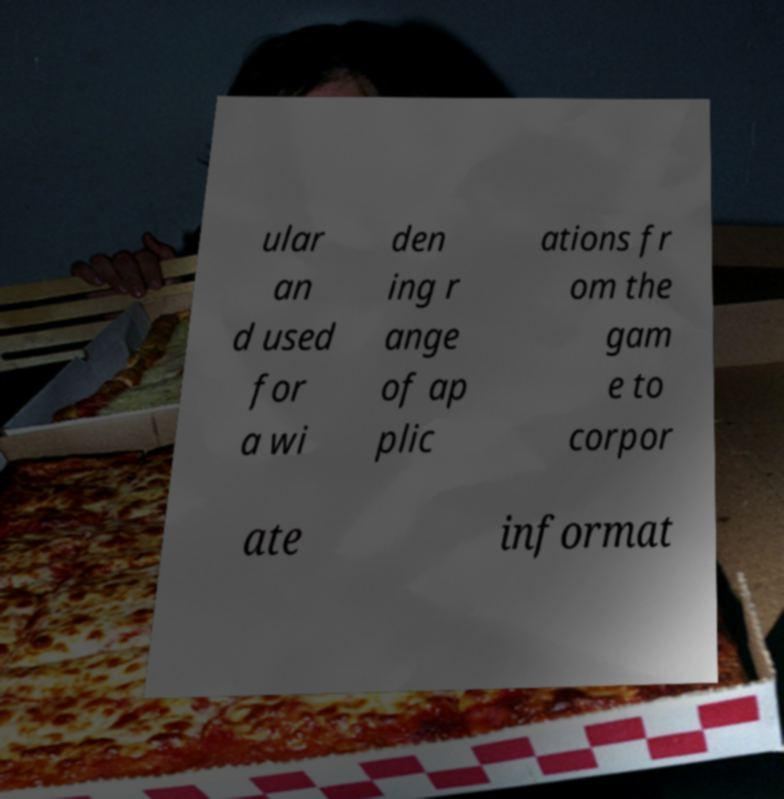Can you read and provide the text displayed in the image?This photo seems to have some interesting text. Can you extract and type it out for me? ular an d used for a wi den ing r ange of ap plic ations fr om the gam e to corpor ate informat 